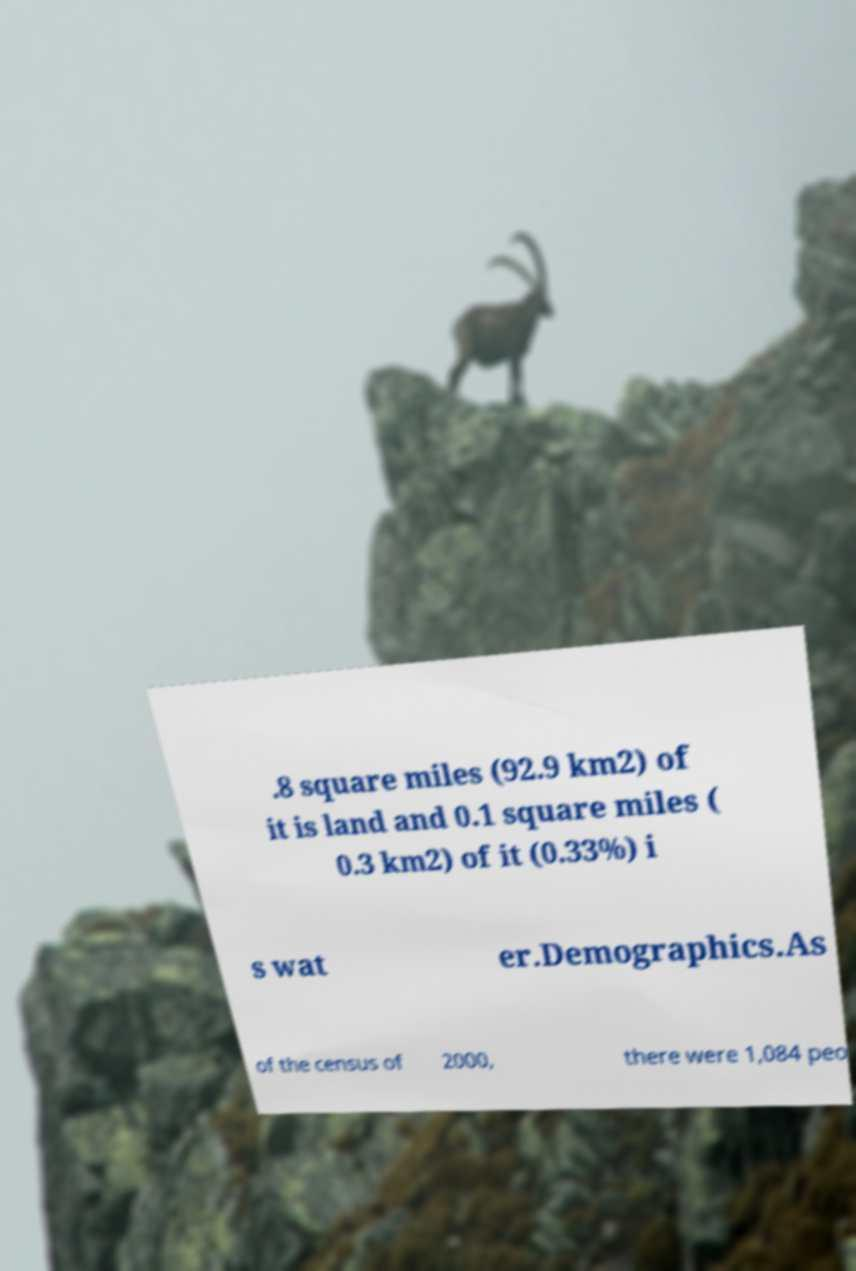Please identify and transcribe the text found in this image. .8 square miles (92.9 km2) of it is land and 0.1 square miles ( 0.3 km2) of it (0.33%) i s wat er.Demographics.As of the census of 2000, there were 1,084 peo 